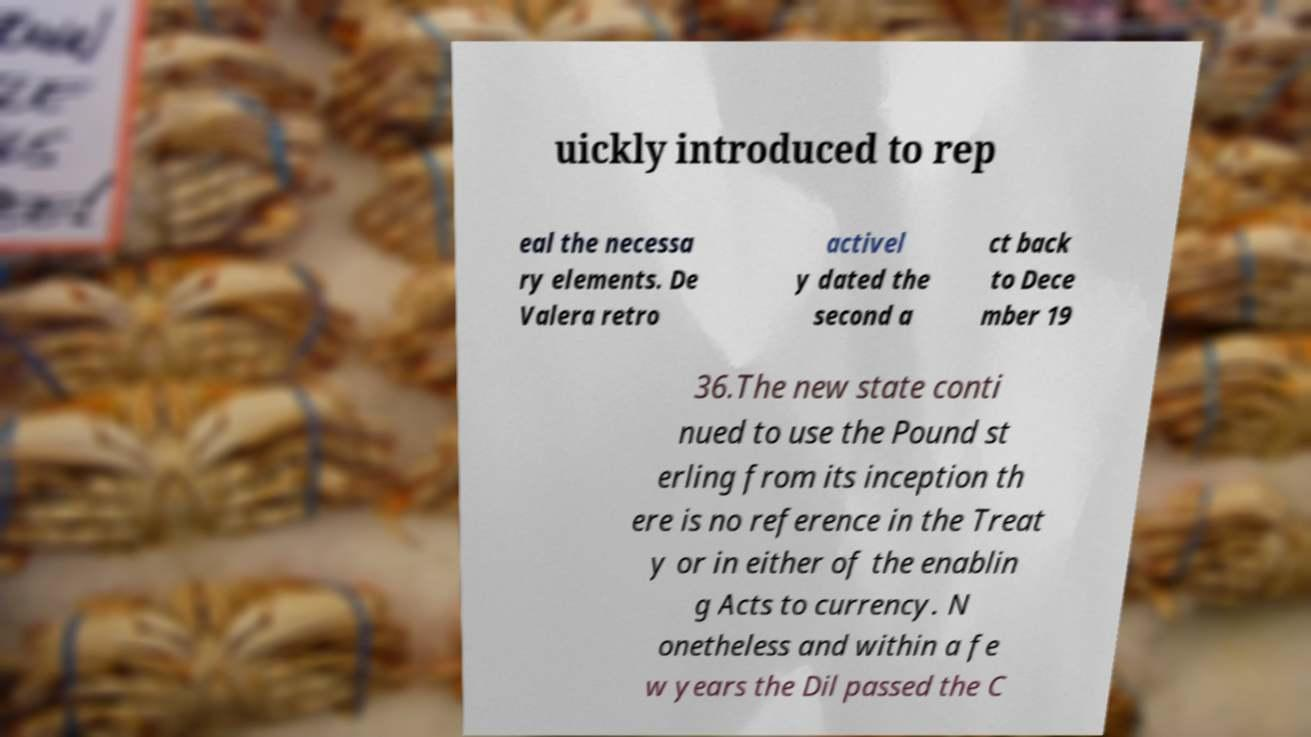Could you extract and type out the text from this image? uickly introduced to rep eal the necessa ry elements. De Valera retro activel y dated the second a ct back to Dece mber 19 36.The new state conti nued to use the Pound st erling from its inception th ere is no reference in the Treat y or in either of the enablin g Acts to currency. N onetheless and within a fe w years the Dil passed the C 